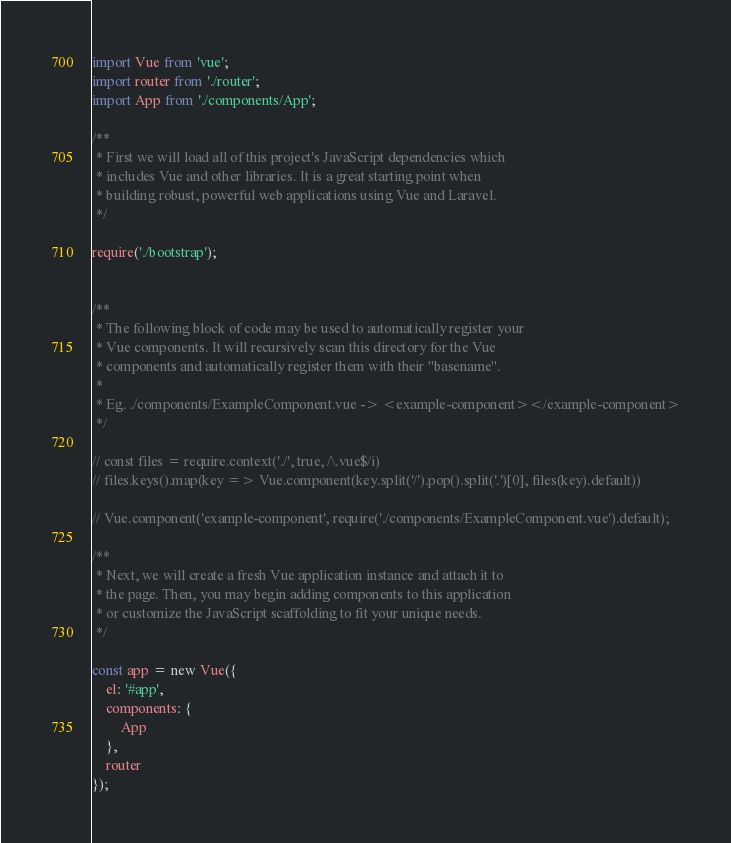Convert code to text. <code><loc_0><loc_0><loc_500><loc_500><_JavaScript_>import Vue from 'vue';
import router from './router';
import App from './components/App';

/**
 * First we will load all of this project's JavaScript dependencies which
 * includes Vue and other libraries. It is a great starting point when
 * building robust, powerful web applications using Vue and Laravel.
 */

require('./bootstrap');


/**
 * The following block of code may be used to automatically register your
 * Vue components. It will recursively scan this directory for the Vue
 * components and automatically register them with their "basename".
 *
 * Eg. ./components/ExampleComponent.vue -> <example-component></example-component>
 */

// const files = require.context('./', true, /\.vue$/i)
// files.keys().map(key => Vue.component(key.split('/').pop().split('.')[0], files(key).default))

// Vue.component('example-component', require('./components/ExampleComponent.vue').default);

/**
 * Next, we will create a fresh Vue application instance and attach it to
 * the page. Then, you may begin adding components to this application
 * or customize the JavaScript scaffolding to fit your unique needs.
 */

const app = new Vue({
    el: '#app',
    components: {
        App
    },
    router
});
</code> 